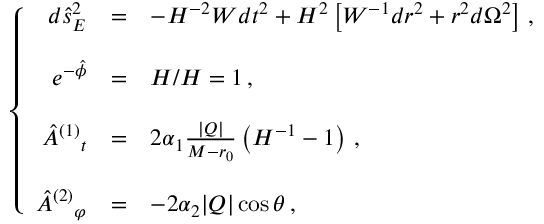<formula> <loc_0><loc_0><loc_500><loc_500>\left \{ \begin{array} { r c l } { { d \hat { s } _ { E } ^ { 2 } } } & { = } & { { - H ^ { - 2 } W d t ^ { 2 } + H ^ { 2 } \left [ W ^ { - 1 } d r ^ { 2 } + r ^ { 2 } d \Omega ^ { 2 } \right ] \, , } } \\ { { e ^ { - \hat { \phi } } } } & { = } & { H / H = 1 \, , } \\ { { \hat { A } ^ { ( 1 ) _ { t } } } & { = } & { { 2 \alpha _ { 1 } \frac { | Q | } { M - r _ { 0 } } \left ( H ^ { - 1 } - 1 \right ) \, , } } \\ { { \hat { A } ^ { ( 2 ) _ { \varphi } } } & { = } & { { - 2 \alpha _ { 2 } | Q | \cos \theta \, , } } \end{array}</formula> 